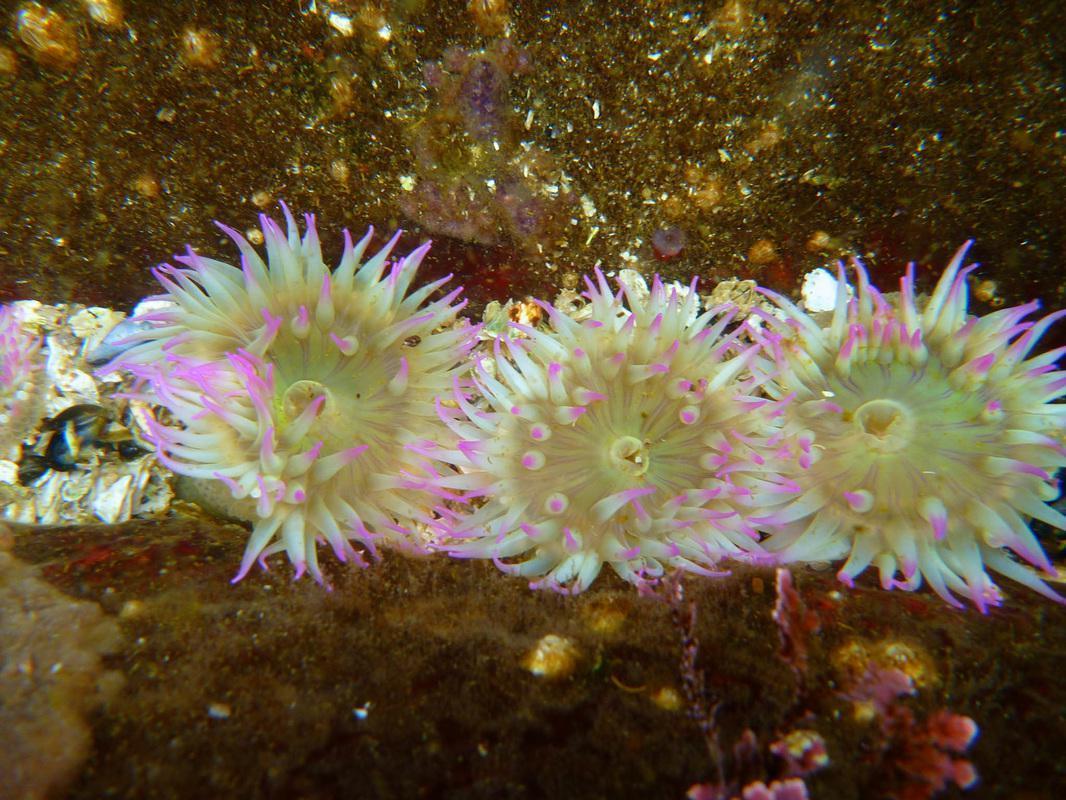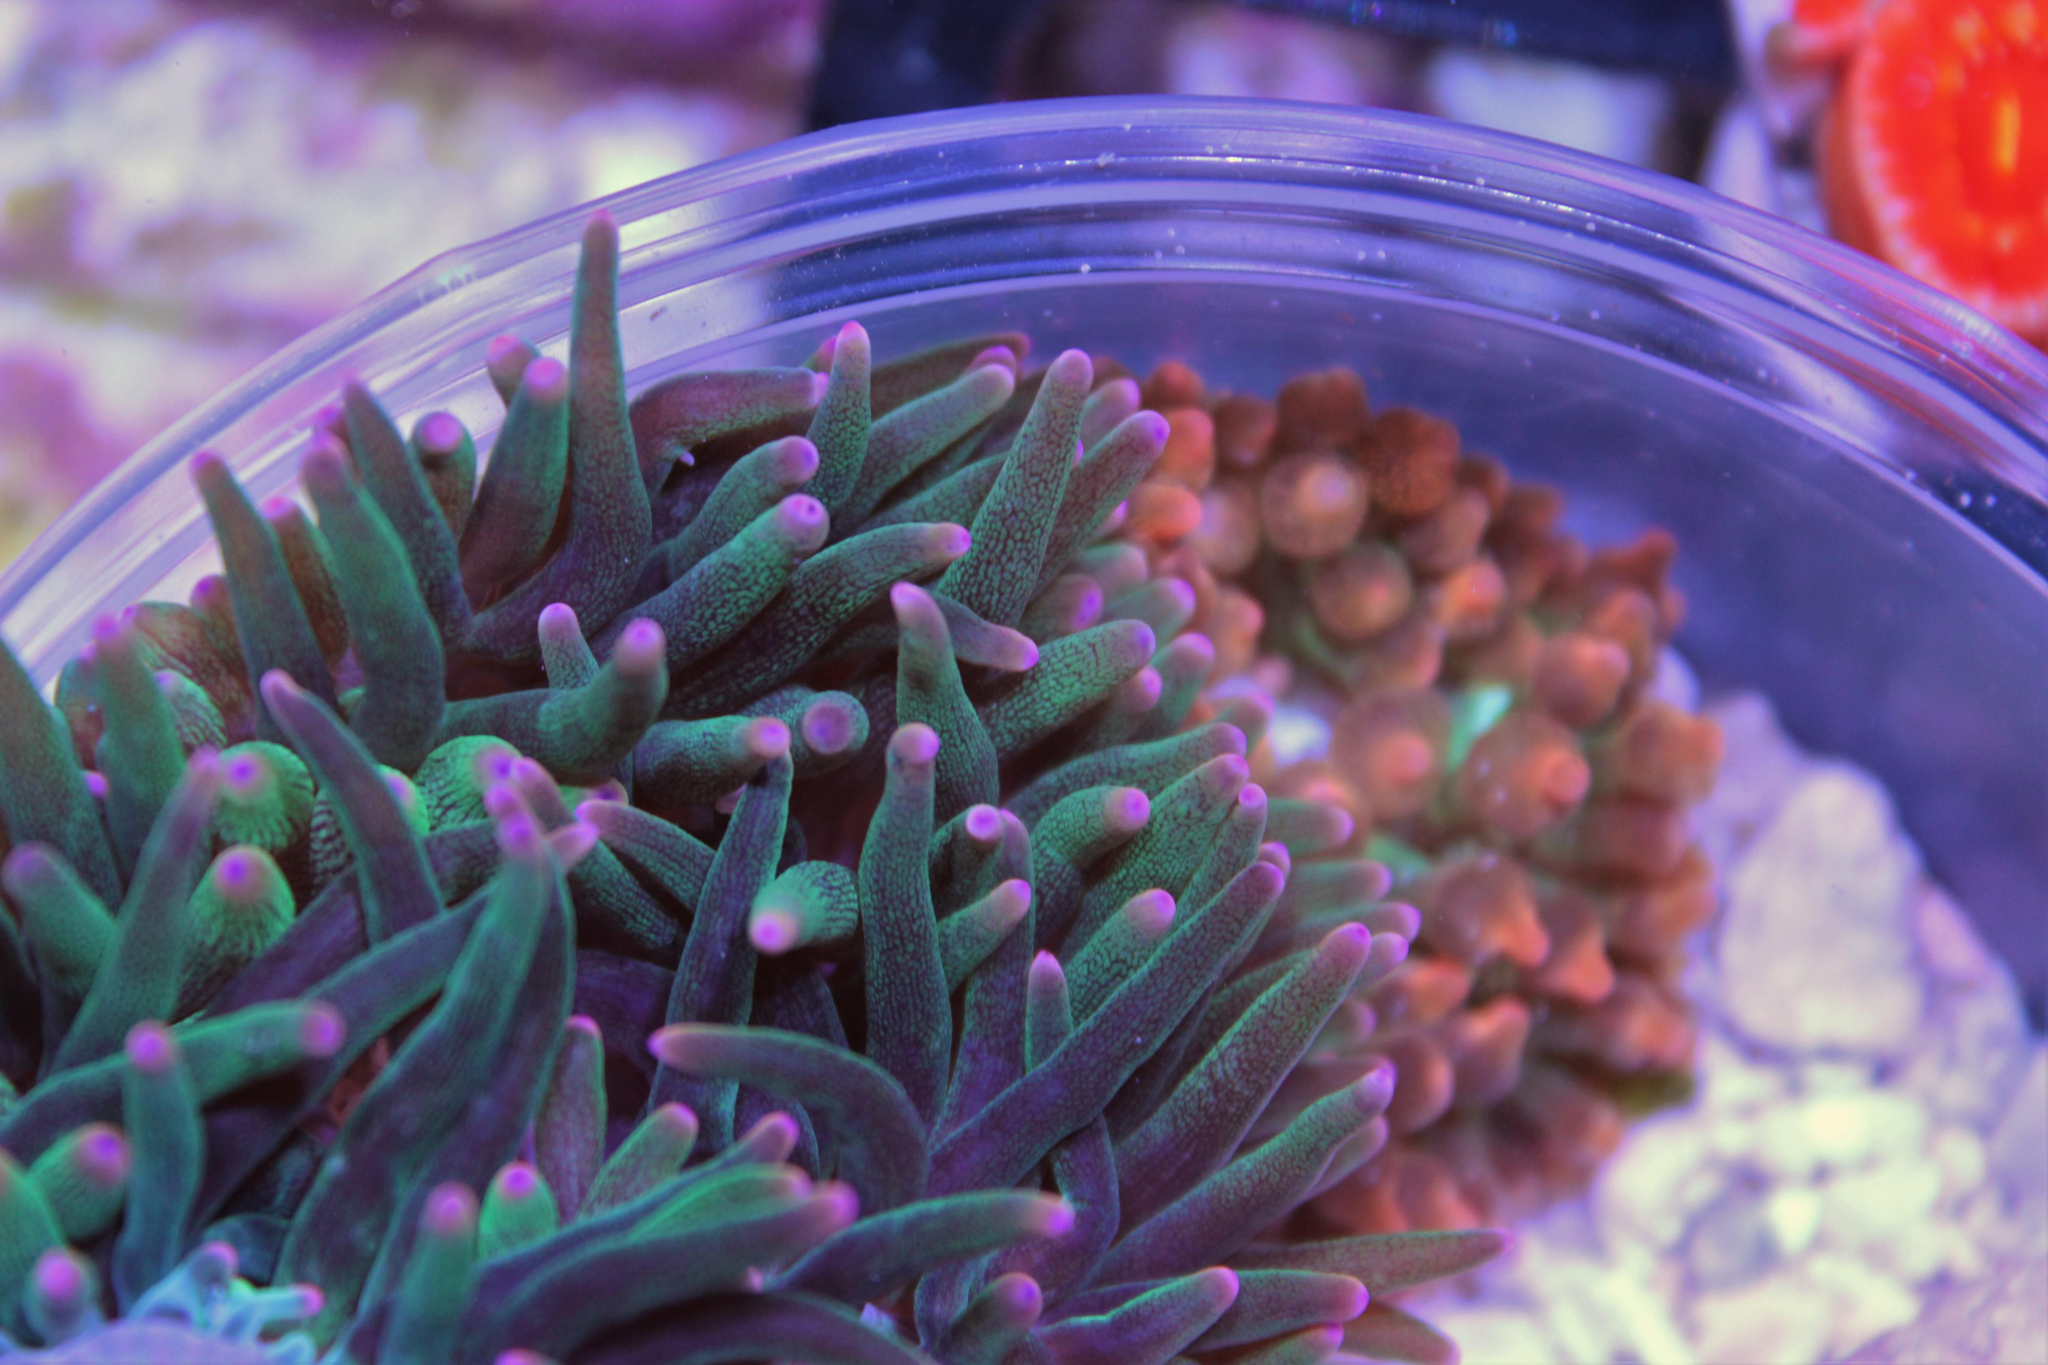The first image is the image on the left, the second image is the image on the right. Evaluate the accuracy of this statement regarding the images: "An image shows the spotted pink stalk of one anemone.". Is it true? Answer yes or no. No. The first image is the image on the left, the second image is the image on the right. Given the left and right images, does the statement "There are more sea plants in the image on the left than in the image on the right." hold true? Answer yes or no. Yes. 